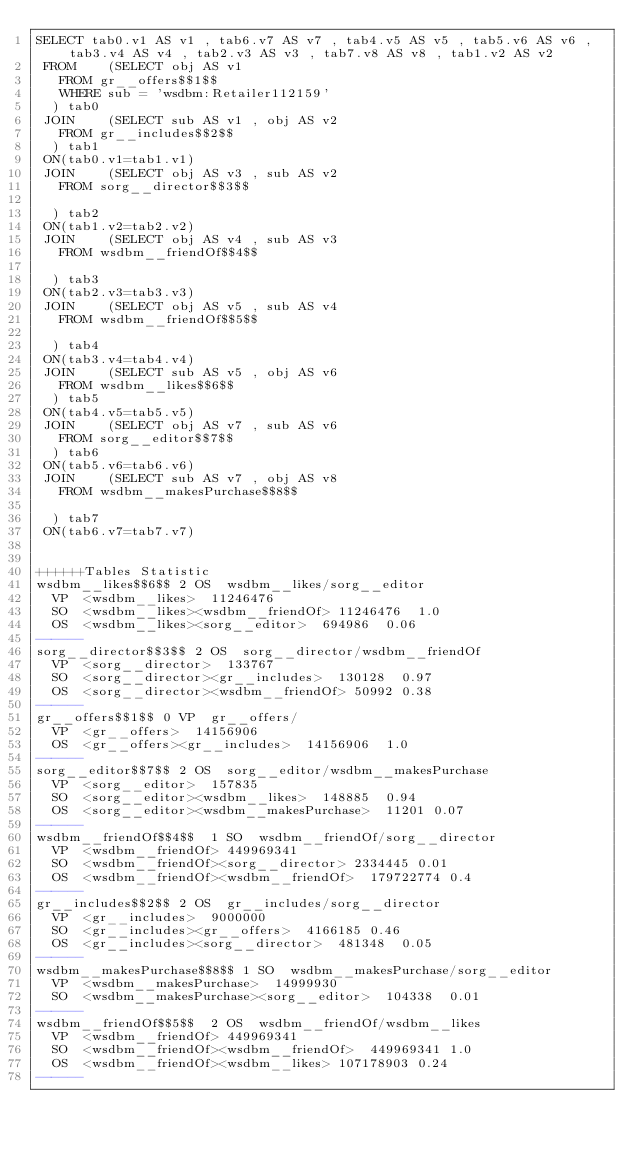Convert code to text. <code><loc_0><loc_0><loc_500><loc_500><_SQL_>SELECT tab0.v1 AS v1 , tab6.v7 AS v7 , tab4.v5 AS v5 , tab5.v6 AS v6 , tab3.v4 AS v4 , tab2.v3 AS v3 , tab7.v8 AS v8 , tab1.v2 AS v2 
 FROM    (SELECT obj AS v1 
	 FROM gr__offers$$1$$ 
	 WHERE sub = 'wsdbm:Retailer112159'
	) tab0
 JOIN    (SELECT sub AS v1 , obj AS v2 
	 FROM gr__includes$$2$$
	) tab1
 ON(tab0.v1=tab1.v1)
 JOIN    (SELECT obj AS v3 , sub AS v2 
	 FROM sorg__director$$3$$
	
	) tab2
 ON(tab1.v2=tab2.v2)
 JOIN    (SELECT obj AS v4 , sub AS v3 
	 FROM wsdbm__friendOf$$4$$
	
	) tab3
 ON(tab2.v3=tab3.v3)
 JOIN    (SELECT obj AS v5 , sub AS v4 
	 FROM wsdbm__friendOf$$5$$
	
	) tab4
 ON(tab3.v4=tab4.v4)
 JOIN    (SELECT sub AS v5 , obj AS v6 
	 FROM wsdbm__likes$$6$$
	) tab5
 ON(tab4.v5=tab5.v5)
 JOIN    (SELECT obj AS v7 , sub AS v6 
	 FROM sorg__editor$$7$$
	) tab6
 ON(tab5.v6=tab6.v6)
 JOIN    (SELECT sub AS v7 , obj AS v8 
	 FROM wsdbm__makesPurchase$$8$$
	
	) tab7
 ON(tab6.v7=tab7.v7)


++++++Tables Statistic
wsdbm__likes$$6$$	2	OS	wsdbm__likes/sorg__editor
	VP	<wsdbm__likes>	11246476
	SO	<wsdbm__likes><wsdbm__friendOf>	11246476	1.0
	OS	<wsdbm__likes><sorg__editor>	694986	0.06
------
sorg__director$$3$$	2	OS	sorg__director/wsdbm__friendOf
	VP	<sorg__director>	133767
	SO	<sorg__director><gr__includes>	130128	0.97
	OS	<sorg__director><wsdbm__friendOf>	50992	0.38
------
gr__offers$$1$$	0	VP	gr__offers/
	VP	<gr__offers>	14156906
	OS	<gr__offers><gr__includes>	14156906	1.0
------
sorg__editor$$7$$	2	OS	sorg__editor/wsdbm__makesPurchase
	VP	<sorg__editor>	157835
	SO	<sorg__editor><wsdbm__likes>	148885	0.94
	OS	<sorg__editor><wsdbm__makesPurchase>	11201	0.07
------
wsdbm__friendOf$$4$$	1	SO	wsdbm__friendOf/sorg__director
	VP	<wsdbm__friendOf>	449969341
	SO	<wsdbm__friendOf><sorg__director>	2334445	0.01
	OS	<wsdbm__friendOf><wsdbm__friendOf>	179722774	0.4
------
gr__includes$$2$$	2	OS	gr__includes/sorg__director
	VP	<gr__includes>	9000000
	SO	<gr__includes><gr__offers>	4166185	0.46
	OS	<gr__includes><sorg__director>	481348	0.05
------
wsdbm__makesPurchase$$8$$	1	SO	wsdbm__makesPurchase/sorg__editor
	VP	<wsdbm__makesPurchase>	14999930
	SO	<wsdbm__makesPurchase><sorg__editor>	104338	0.01
------
wsdbm__friendOf$$5$$	2	OS	wsdbm__friendOf/wsdbm__likes
	VP	<wsdbm__friendOf>	449969341
	SO	<wsdbm__friendOf><wsdbm__friendOf>	449969341	1.0
	OS	<wsdbm__friendOf><wsdbm__likes>	107178903	0.24
------
</code> 